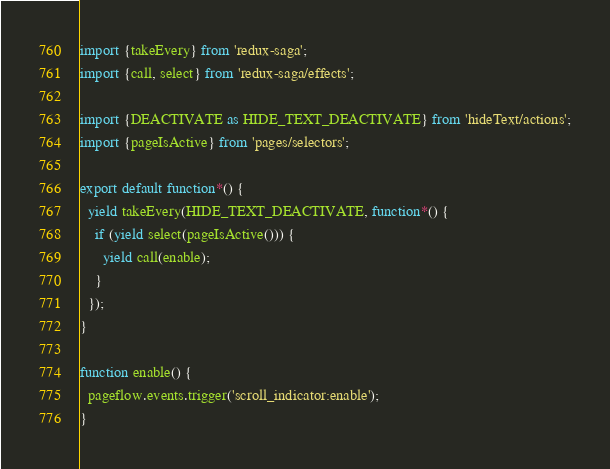<code> <loc_0><loc_0><loc_500><loc_500><_JavaScript_>import {takeEvery} from 'redux-saga';
import {call, select} from 'redux-saga/effects';

import {DEACTIVATE as HIDE_TEXT_DEACTIVATE} from 'hideText/actions';
import {pageIsActive} from 'pages/selectors';

export default function*() {
  yield takeEvery(HIDE_TEXT_DEACTIVATE, function*() {
    if (yield select(pageIsActive())) {
      yield call(enable);
    }
  });
}

function enable() {
  pageflow.events.trigger('scroll_indicator:enable');
}
</code> 